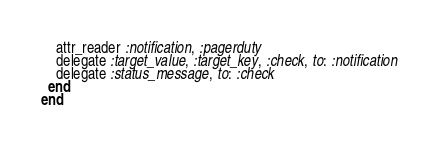Convert code to text. <code><loc_0><loc_0><loc_500><loc_500><_Ruby_>    attr_reader :notification, :pagerduty
    delegate :target_value, :target_key, :check, to: :notification
    delegate :status_message, to: :check
  end
end</code> 